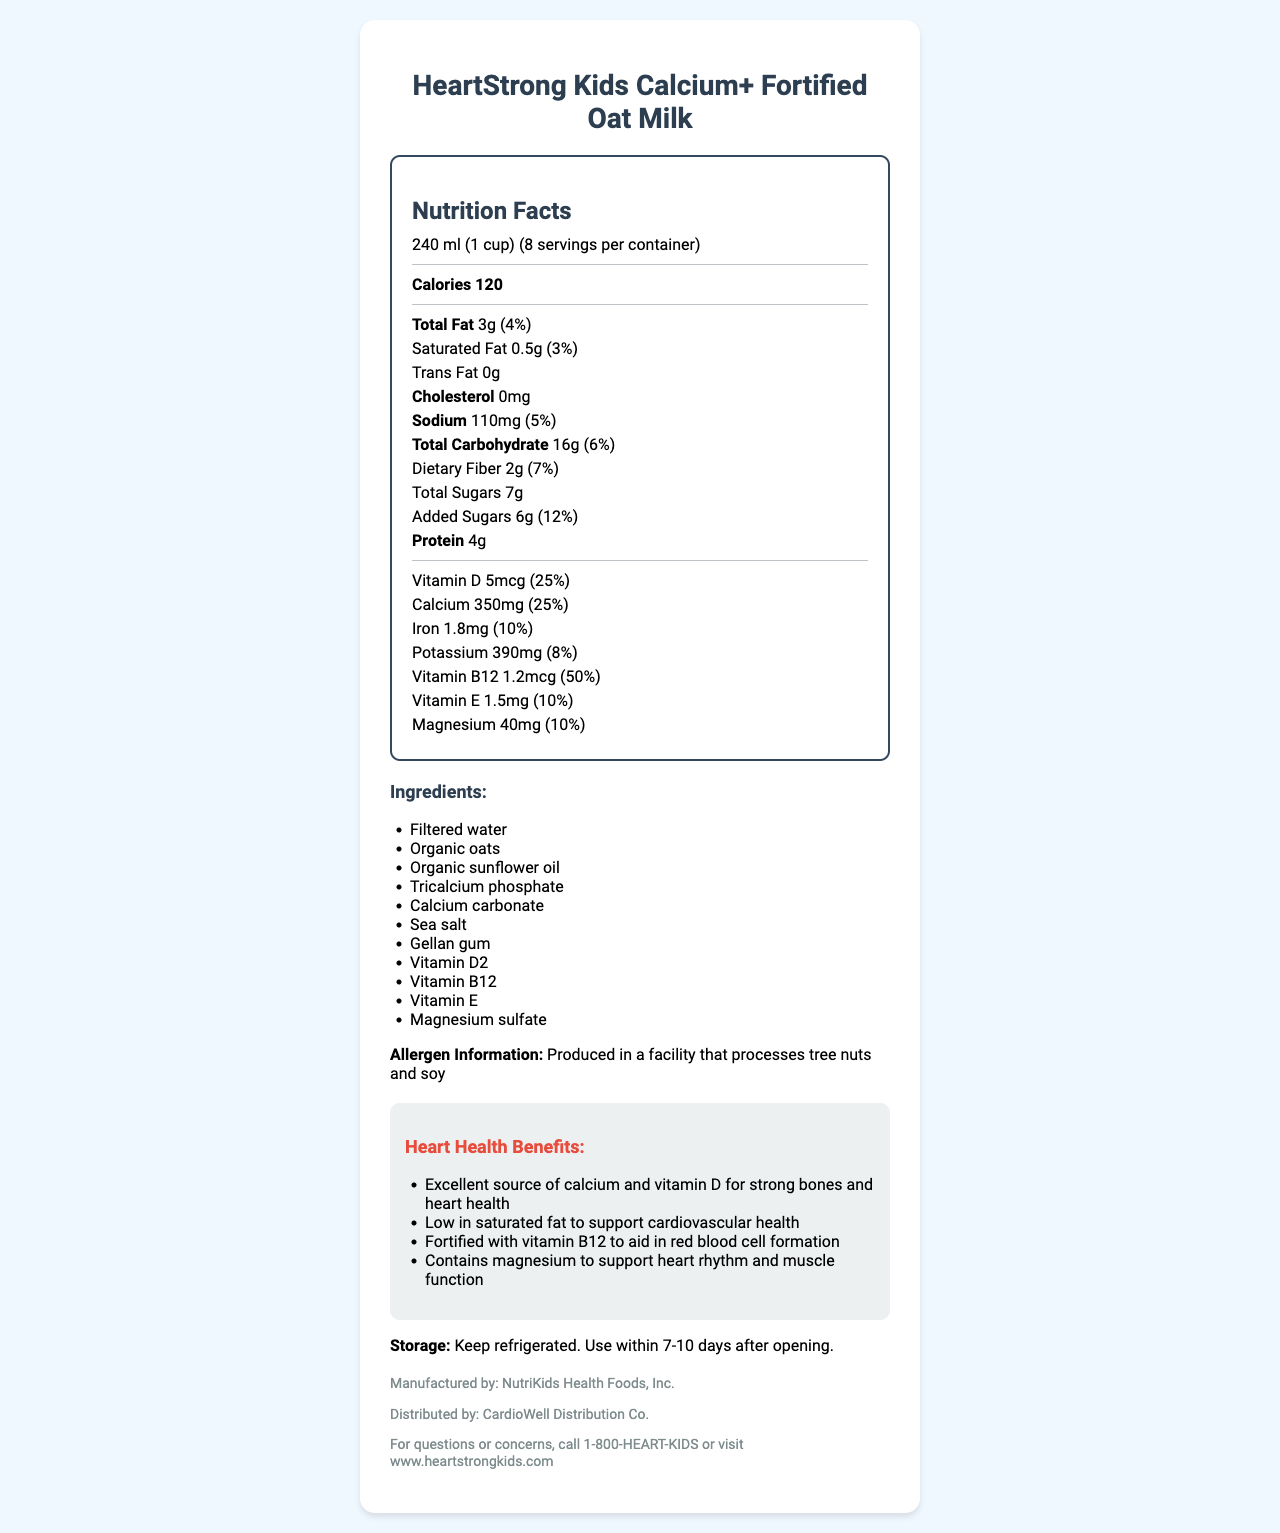what is the serving size of HeartStrong Kids Calcium+ Fortified Oat Milk? The serving size is explicitly listed as 240 ml (1 cup) on the document.
Answer: 240 ml (1 cup) how many calories are in one serving? The document states that there are 120 calories per serving.
Answer: 120 calories how much calcium is provided in one serving? The document lists 350mg of calcium per serving.
Answer: 350mg how much protein does this milk alternative contain per serving? The protein content per serving is stated as 4g.
Answer: 4g what is the daily value percentage of vitamin D in one serving? The document shows that one serving provides 25% of the daily value for vitamin D.
Answer: 25% how many servings are in one container? A. 6 B. 8 C. 10 D. 12 The document indicates that there are 8 servings per container.
Answer: B what is the main ingredient in the product? A. Organic sunflower oil B. Tricalcium phosphate C. Organic oats D. Filtered water The listed ingredients show that filtered water is the main ingredient.
Answer: D is this product low in cholesterol? The document states that the product contains 0mg cholesterol, indicating it is low in cholesterol.
Answer: Yes summarize the purpose and key features of the HeartStrong Kids Calcium+ Fortified Oat Milk. The product offers a range of nutrients important for children with heart conditions, and the summary encapsulates these features.
Answer: The HeartStrong Kids Calcium+ Fortified Oat Milk is designed as a nutritious milk alternative for children, particularly those with heart conditions. It provides essential vitamins and minerals, including high calcium and vitamin D for bone and heart health, is low in saturated fat, and supports cardiovascular health with added vitamin B12 and magnesium. can you find the expiration date on this document? The document does not contain any details regarding the expiration date of the product.
Answer: Not enough information 